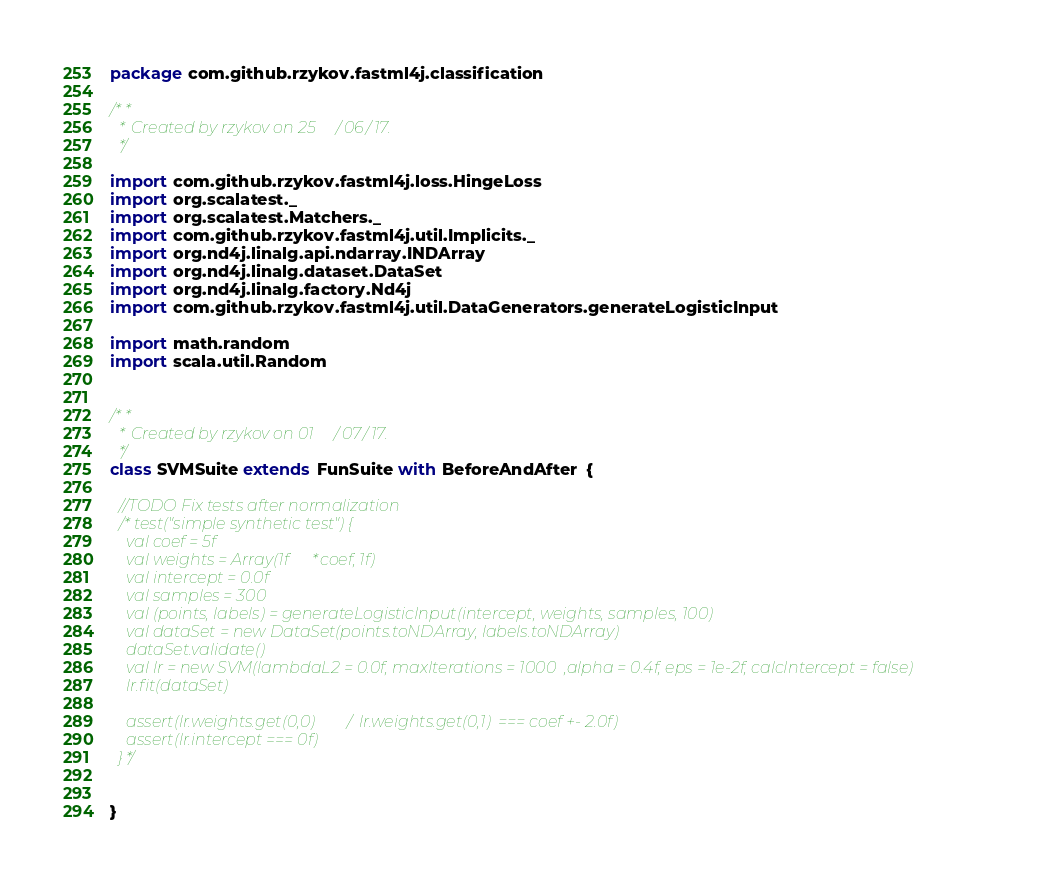Convert code to text. <code><loc_0><loc_0><loc_500><loc_500><_Scala_>package com.github.rzykov.fastml4j.classification

/**
  * Created by rzykov on 25/06/17.
  */

import com.github.rzykov.fastml4j.loss.HingeLoss
import org.scalatest._
import org.scalatest.Matchers._
import com.github.rzykov.fastml4j.util.Implicits._
import org.nd4j.linalg.api.ndarray.INDArray
import org.nd4j.linalg.dataset.DataSet
import org.nd4j.linalg.factory.Nd4j
import com.github.rzykov.fastml4j.util.DataGenerators.generateLogisticInput

import math.random
import scala.util.Random


/**
  * Created by rzykov on 01/07/17.
  */
class SVMSuite extends FunSuite with BeforeAndAfter  {

  //TODO Fix tests after normalization
  /*test("simple synthetic test") {
    val coef = 5f
    val weights = Array(1f*coef, 1f)
    val intercept = 0.0f
    val samples = 300
    val (points, labels) = generateLogisticInput(intercept, weights, samples, 100)
    val dataSet = new DataSet(points.toNDArray, labels.toNDArray)
    dataSet.validate()
    val lr = new SVM(lambdaL2 = 0.0f, maxIterations = 1000  ,alpha = 0.4f, eps = 1e-2f, calcIntercept = false)
    lr.fit(dataSet)

    assert(lr.weights.get(0,0) / lr.weights.get(0,1)  === coef +- 2.0f)
    assert(lr.intercept === 0f)
  }*/


}
</code> 